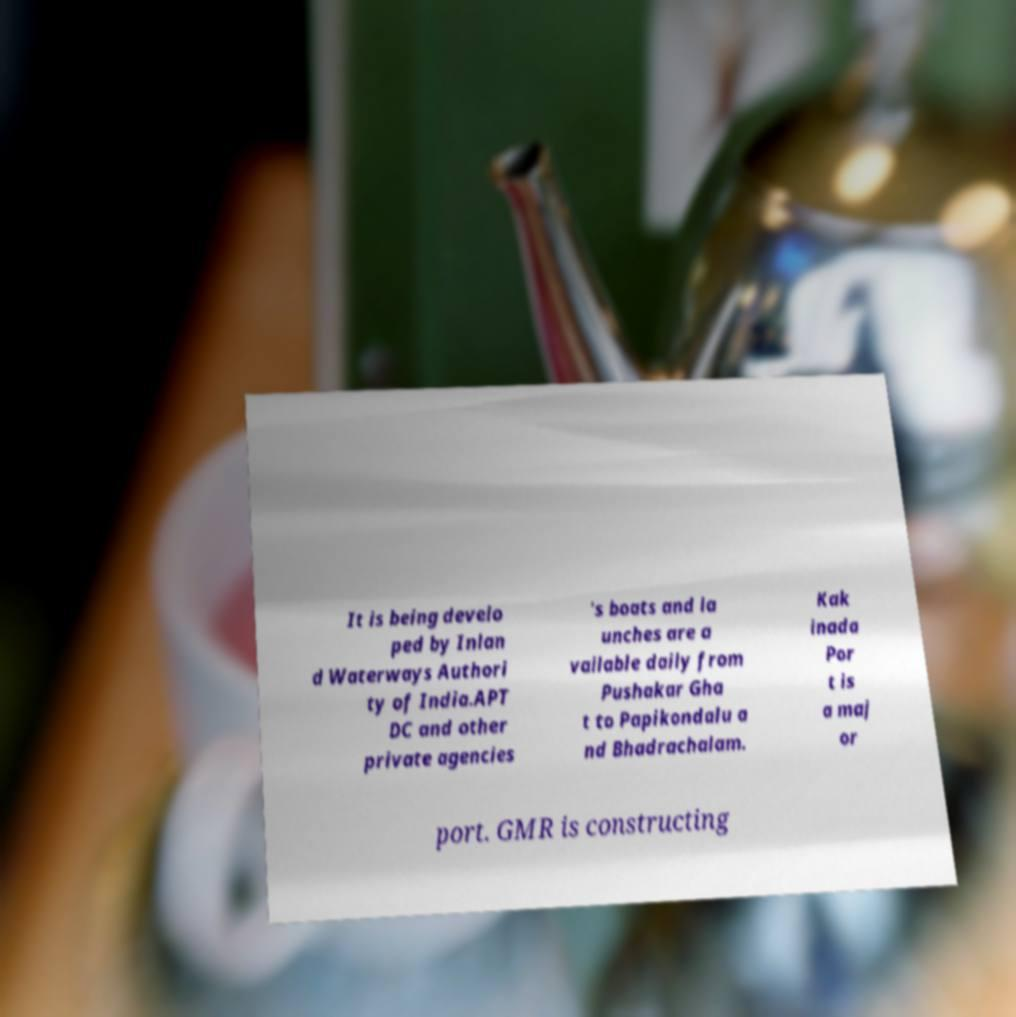What messages or text are displayed in this image? I need them in a readable, typed format. It is being develo ped by Inlan d Waterways Authori ty of India.APT DC and other private agencies 's boats and la unches are a vailable daily from Pushakar Gha t to Papikondalu a nd Bhadrachalam. Kak inada Por t is a maj or port. GMR is constructing 